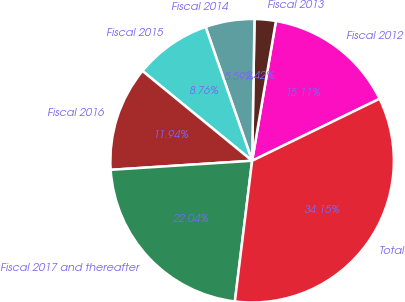Convert chart. <chart><loc_0><loc_0><loc_500><loc_500><pie_chart><fcel>Fiscal 2012<fcel>Fiscal 2013<fcel>Fiscal 2014<fcel>Fiscal 2015<fcel>Fiscal 2016<fcel>Fiscal 2017 and thereafter<fcel>Total<nl><fcel>15.11%<fcel>2.42%<fcel>5.59%<fcel>8.76%<fcel>11.94%<fcel>22.04%<fcel>34.15%<nl></chart> 